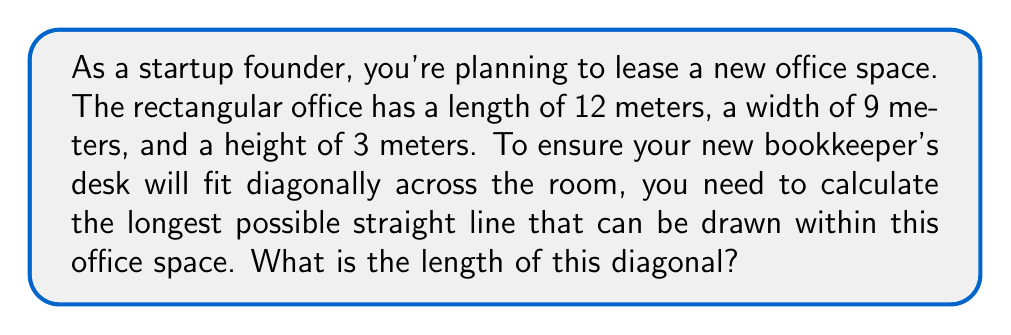What is the answer to this math problem? To solve this problem, we need to use the three-dimensional version of the Pythagorean theorem, also known as the distance formula in 3D space.

Let's define our dimensions:
- Length (l) = 12 meters
- Width (w) = 9 meters
- Height (h) = 3 meters

The diagonal of a rectangular prism can be calculated using the formula:

$$ d = \sqrt{l^2 + w^2 + h^2} $$

Where d is the diagonal length.

Let's substitute our values:

$$ d = \sqrt{12^2 + 9^2 + 3^2} $$

Now, let's calculate step by step:

1) First, calculate the squares:
   $12^2 = 144$
   $9^2 = 81$
   $3^2 = 9$

2) Add these values under the square root:
   $$ d = \sqrt{144 + 81 + 9} $$

3) Simplify under the square root:
   $$ d = \sqrt{234} $$

4) Calculate the square root:
   $$ d \approx 15.30 $$

[asy]
import three;

size(200);
currentprojection=perspective(6,3,2);

triple A=(0,0,0), B=(12,0,0), C=(12,9,0), D=(0,9,0), E=(0,0,3), F=(12,0,3), G=(12,9,3), H=(0,9,3);

draw(A--B--C--D--cycle);
draw(E--F--G--H--cycle);
draw(A--E);
draw(B--F);
draw(C--G);
draw(D--H);

draw(A--G,red);

label("12m",B-(0,0.5,0),S);
label("9m",C-(6,0,0),E);
label("3m",E-(0.5,0,0),W);

</asy>

The red line in the diagram represents the diagonal we've calculated.
Answer: The diagonal length of the office space is approximately 15.30 meters. 